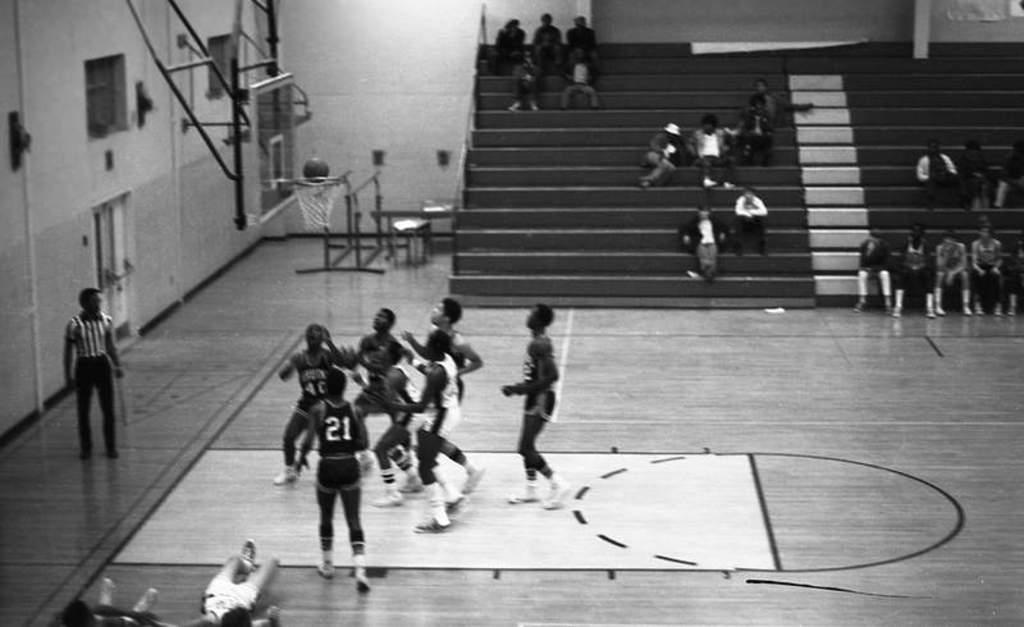<image>
Summarize the visual content of the image. a black and white photo of a basketball team crowding the hoop, player 21 the only visible jersey number 